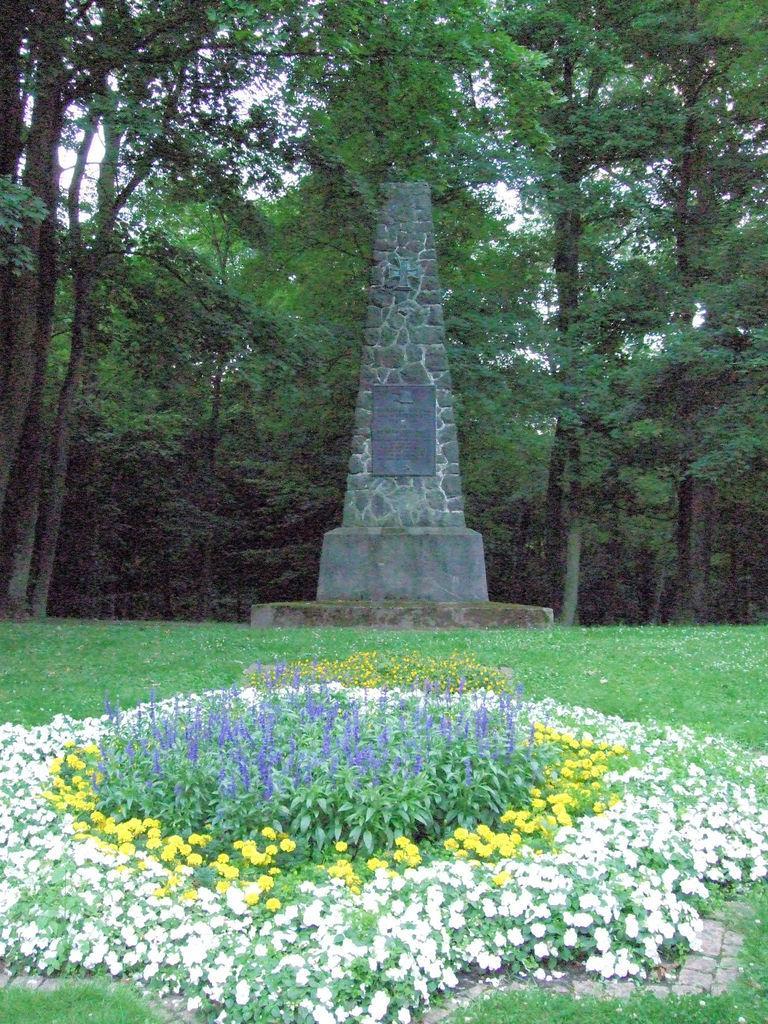Please provide a concise description of this image. In this image, we can see some plants. There is a foundation stone in the middle of the image. In the background of the image, there are some trees. 